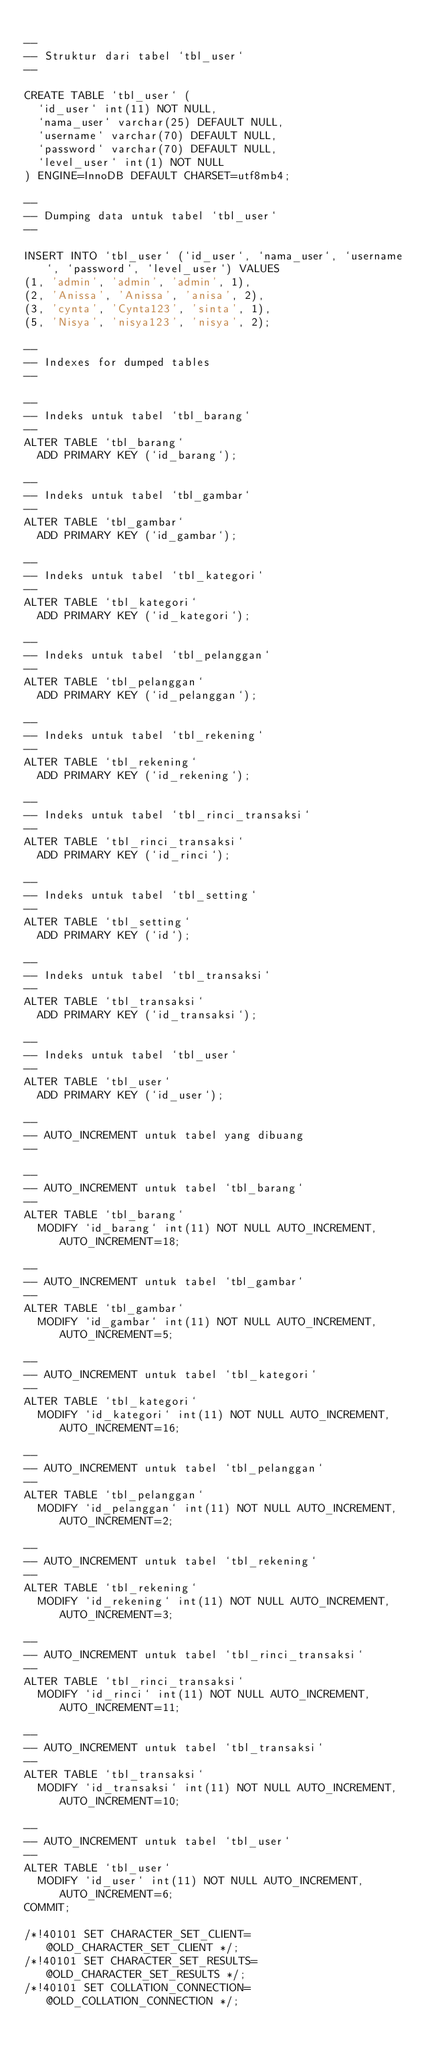<code> <loc_0><loc_0><loc_500><loc_500><_SQL_>
--
-- Struktur dari tabel `tbl_user`
--

CREATE TABLE `tbl_user` (
  `id_user` int(11) NOT NULL,
  `nama_user` varchar(25) DEFAULT NULL,
  `username` varchar(70) DEFAULT NULL,
  `password` varchar(70) DEFAULT NULL,
  `level_user` int(1) NOT NULL
) ENGINE=InnoDB DEFAULT CHARSET=utf8mb4;

--
-- Dumping data untuk tabel `tbl_user`
--

INSERT INTO `tbl_user` (`id_user`, `nama_user`, `username`, `password`, `level_user`) VALUES
(1, 'admin', 'admin', 'admin', 1),
(2, 'Anissa', 'Anissa', 'anisa', 2),
(3, 'cynta', 'Cynta123', 'sinta', 1),
(5, 'Nisya', 'nisya123', 'nisya', 2);

--
-- Indexes for dumped tables
--

--
-- Indeks untuk tabel `tbl_barang`
--
ALTER TABLE `tbl_barang`
  ADD PRIMARY KEY (`id_barang`);

--
-- Indeks untuk tabel `tbl_gambar`
--
ALTER TABLE `tbl_gambar`
  ADD PRIMARY KEY (`id_gambar`);

--
-- Indeks untuk tabel `tbl_kategori`
--
ALTER TABLE `tbl_kategori`
  ADD PRIMARY KEY (`id_kategori`);

--
-- Indeks untuk tabel `tbl_pelanggan`
--
ALTER TABLE `tbl_pelanggan`
  ADD PRIMARY KEY (`id_pelanggan`);

--
-- Indeks untuk tabel `tbl_rekening`
--
ALTER TABLE `tbl_rekening`
  ADD PRIMARY KEY (`id_rekening`);

--
-- Indeks untuk tabel `tbl_rinci_transaksi`
--
ALTER TABLE `tbl_rinci_transaksi`
  ADD PRIMARY KEY (`id_rinci`);

--
-- Indeks untuk tabel `tbl_setting`
--
ALTER TABLE `tbl_setting`
  ADD PRIMARY KEY (`id`);

--
-- Indeks untuk tabel `tbl_transaksi`
--
ALTER TABLE `tbl_transaksi`
  ADD PRIMARY KEY (`id_transaksi`);

--
-- Indeks untuk tabel `tbl_user`
--
ALTER TABLE `tbl_user`
  ADD PRIMARY KEY (`id_user`);

--
-- AUTO_INCREMENT untuk tabel yang dibuang
--

--
-- AUTO_INCREMENT untuk tabel `tbl_barang`
--
ALTER TABLE `tbl_barang`
  MODIFY `id_barang` int(11) NOT NULL AUTO_INCREMENT, AUTO_INCREMENT=18;

--
-- AUTO_INCREMENT untuk tabel `tbl_gambar`
--
ALTER TABLE `tbl_gambar`
  MODIFY `id_gambar` int(11) NOT NULL AUTO_INCREMENT, AUTO_INCREMENT=5;

--
-- AUTO_INCREMENT untuk tabel `tbl_kategori`
--
ALTER TABLE `tbl_kategori`
  MODIFY `id_kategori` int(11) NOT NULL AUTO_INCREMENT, AUTO_INCREMENT=16;

--
-- AUTO_INCREMENT untuk tabel `tbl_pelanggan`
--
ALTER TABLE `tbl_pelanggan`
  MODIFY `id_pelanggan` int(11) NOT NULL AUTO_INCREMENT, AUTO_INCREMENT=2;

--
-- AUTO_INCREMENT untuk tabel `tbl_rekening`
--
ALTER TABLE `tbl_rekening`
  MODIFY `id_rekening` int(11) NOT NULL AUTO_INCREMENT, AUTO_INCREMENT=3;

--
-- AUTO_INCREMENT untuk tabel `tbl_rinci_transaksi`
--
ALTER TABLE `tbl_rinci_transaksi`
  MODIFY `id_rinci` int(11) NOT NULL AUTO_INCREMENT, AUTO_INCREMENT=11;

--
-- AUTO_INCREMENT untuk tabel `tbl_transaksi`
--
ALTER TABLE `tbl_transaksi`
  MODIFY `id_transaksi` int(11) NOT NULL AUTO_INCREMENT, AUTO_INCREMENT=10;

--
-- AUTO_INCREMENT untuk tabel `tbl_user`
--
ALTER TABLE `tbl_user`
  MODIFY `id_user` int(11) NOT NULL AUTO_INCREMENT, AUTO_INCREMENT=6;
COMMIT;

/*!40101 SET CHARACTER_SET_CLIENT=@OLD_CHARACTER_SET_CLIENT */;
/*!40101 SET CHARACTER_SET_RESULTS=@OLD_CHARACTER_SET_RESULTS */;
/*!40101 SET COLLATION_CONNECTION=@OLD_COLLATION_CONNECTION */;
</code> 